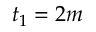<formula> <loc_0><loc_0><loc_500><loc_500>t _ { 1 } = 2 m</formula> 